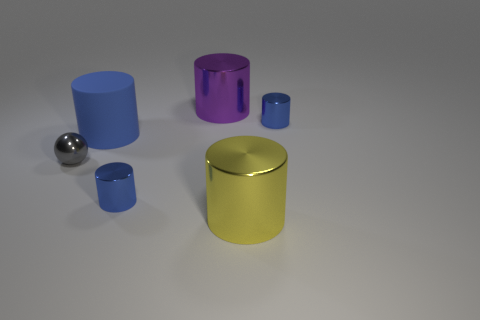How many tiny green cylinders are there?
Your answer should be very brief. 0. There is a tiny object that is to the left of the cylinder that is on the left side of the small blue metal thing left of the purple cylinder; what is its color?
Make the answer very short. Gray. What number of tiny blue cylinders are both in front of the gray metal thing and behind the blue rubber object?
Make the answer very short. 0. What number of shiny things are large blue objects or blue blocks?
Provide a short and direct response. 0. What is the purple object behind the large shiny object in front of the small gray metallic object made of?
Offer a very short reply. Metal. There is a purple thing that is the same size as the blue rubber object; what is its shape?
Your response must be concise. Cylinder. Are there fewer blue cylinders than big blue cylinders?
Provide a succinct answer. No. Are there any yellow metallic cylinders to the right of the tiny blue cylinder that is in front of the big blue matte thing?
Keep it short and to the point. Yes. The tiny gray thing that is made of the same material as the yellow object is what shape?
Ensure brevity in your answer.  Sphere. Is there anything else of the same color as the rubber cylinder?
Offer a terse response. Yes. 